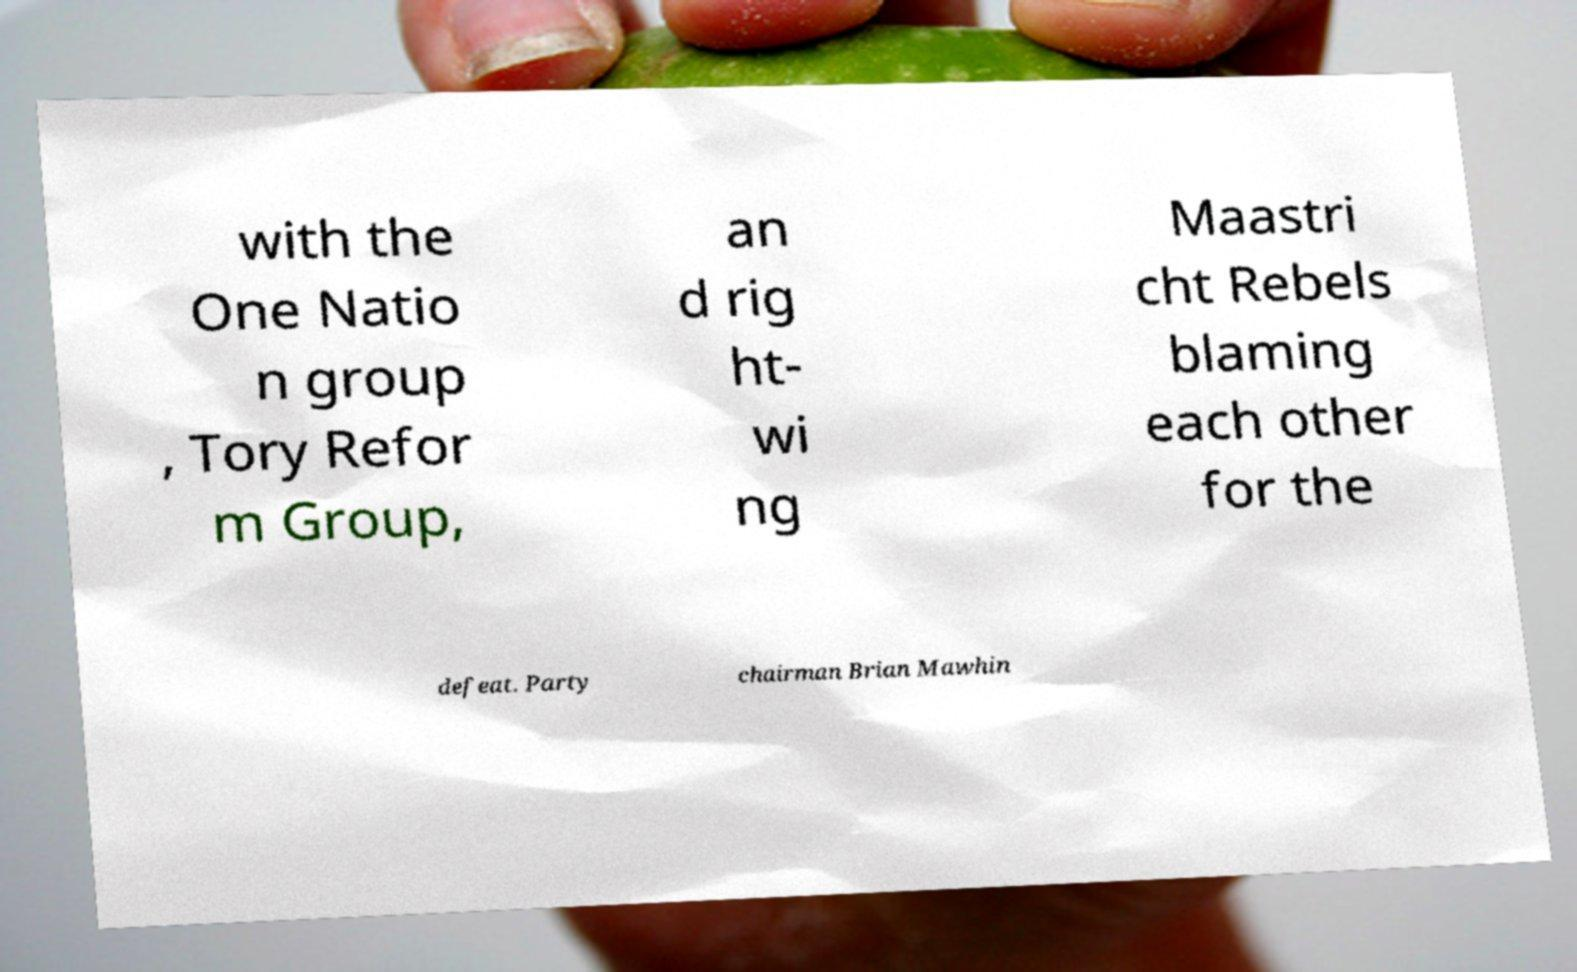Could you assist in decoding the text presented in this image and type it out clearly? with the One Natio n group , Tory Refor m Group, an d rig ht- wi ng Maastri cht Rebels blaming each other for the defeat. Party chairman Brian Mawhin 